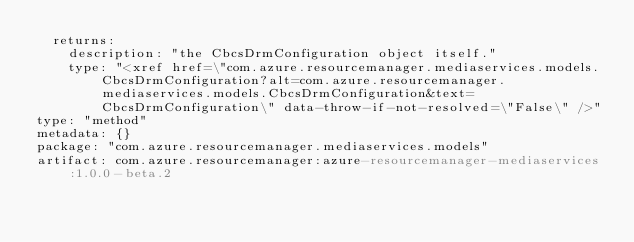<code> <loc_0><loc_0><loc_500><loc_500><_YAML_>  returns:
    description: "the CbcsDrmConfiguration object itself."
    type: "<xref href=\"com.azure.resourcemanager.mediaservices.models.CbcsDrmConfiguration?alt=com.azure.resourcemanager.mediaservices.models.CbcsDrmConfiguration&text=CbcsDrmConfiguration\" data-throw-if-not-resolved=\"False\" />"
type: "method"
metadata: {}
package: "com.azure.resourcemanager.mediaservices.models"
artifact: com.azure.resourcemanager:azure-resourcemanager-mediaservices:1.0.0-beta.2
</code> 